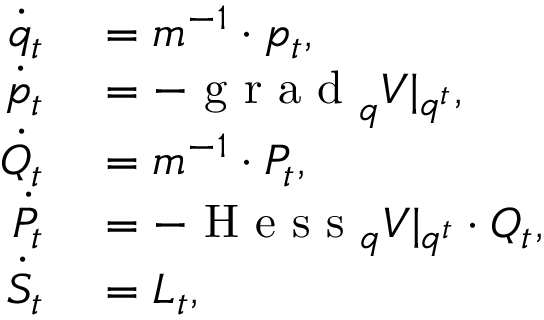Convert formula to latex. <formula><loc_0><loc_0><loc_500><loc_500>\begin{array} { r l } { \ D o t { q } _ { t } } & = m ^ { - 1 } \cdot p _ { t } , } \\ { \ D o t { p } _ { t } } & = - g r a d _ { q } V | _ { q ^ { t } } , } \\ { \ D o t { Q } _ { t } } & = m ^ { - 1 } \cdot P _ { t } , } \\ { \ D o t { P } _ { t } } & = - H e s s _ { q } V | _ { q ^ { t } } \cdot Q _ { t } , } \\ { \ D o t { S } _ { t } } & = L _ { t } , } \end{array}</formula> 